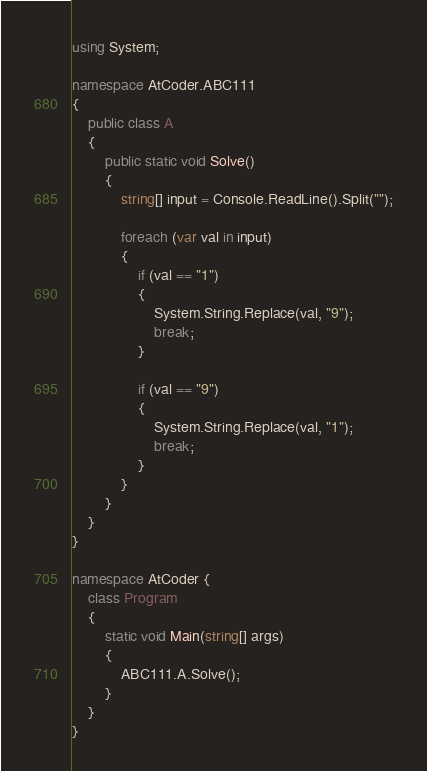Convert code to text. <code><loc_0><loc_0><loc_500><loc_500><_C#_>using System;

namespace AtCoder.ABC111
{
    public class A
    {
        public static void Solve()
        {
            string[] input = Console.ReadLine().Split("");

            foreach (var val in input)
            {
                if (val == "1")
                {
                    System.String.Replace(val, "9");
                    break;
                }

                if (val == "9")
                {
                    System.String.Replace(val, "1");
                    break;
                }
            }
        }    
    }
}

namespace AtCoder {
    class Program
    {
        static void Main(string[] args)
        {
            ABC111.A.Solve();
        }
    }
}
</code> 